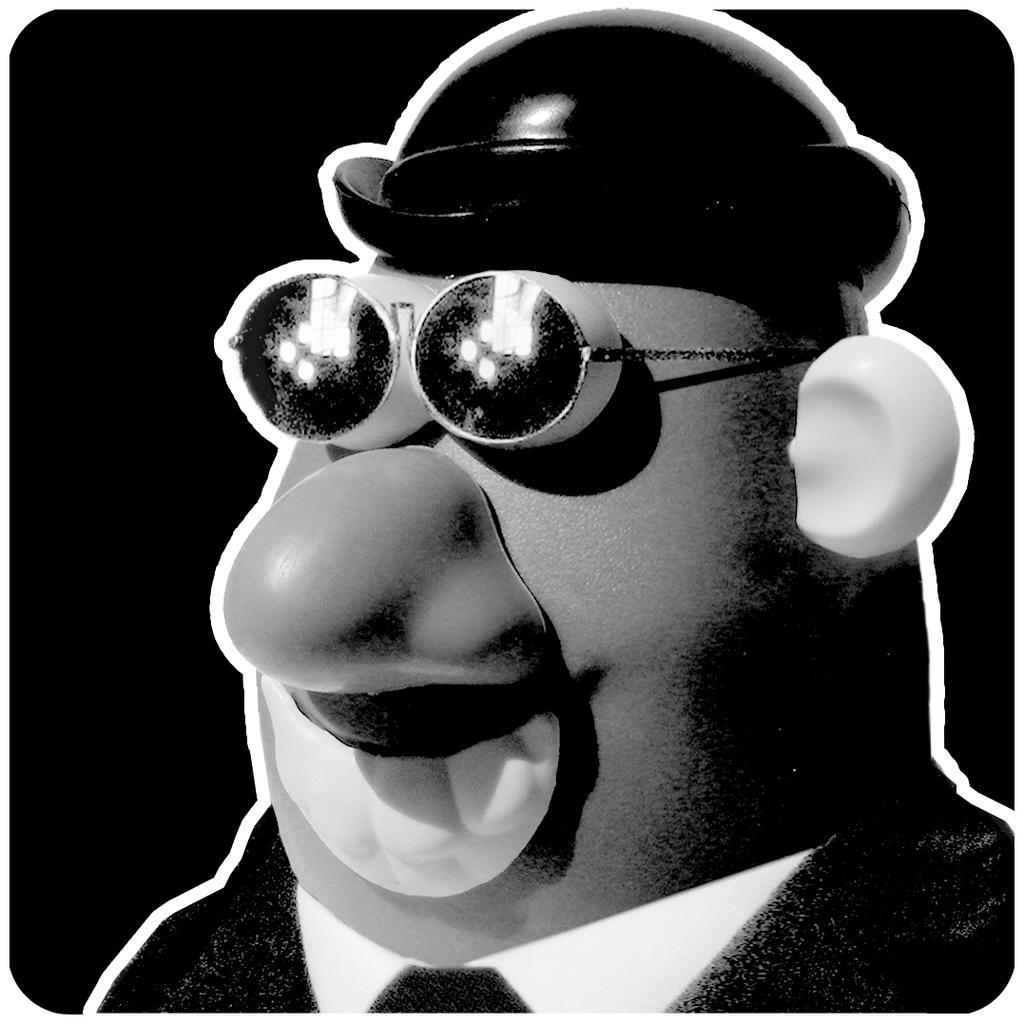Describe this image in one or two sentences. In this picture we can see a cartoon. Background is black in color. 